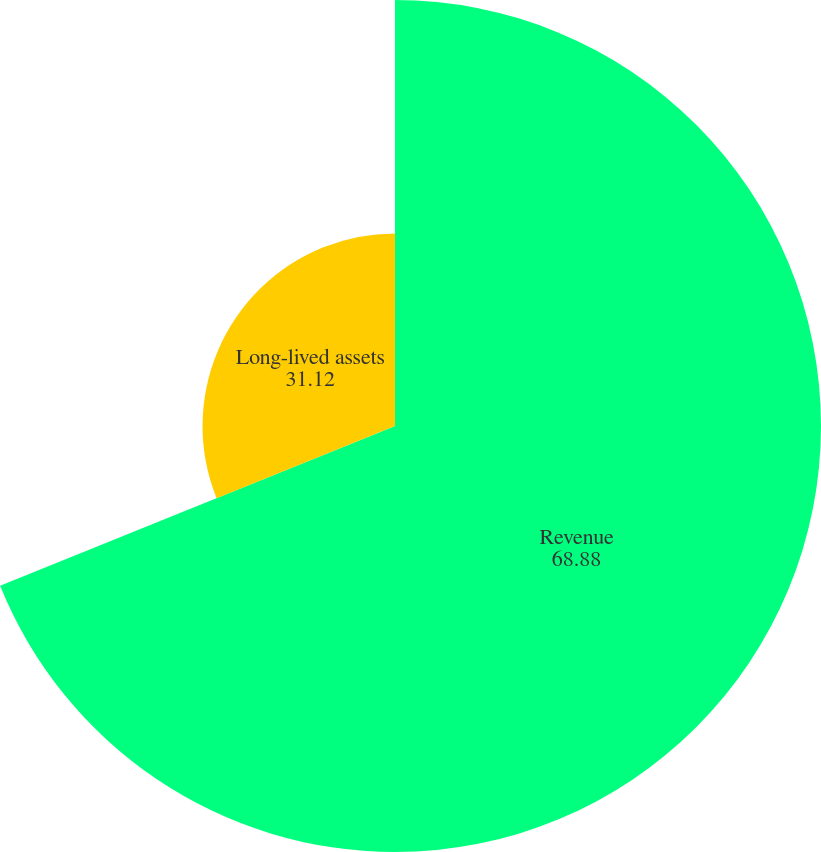Convert chart to OTSL. <chart><loc_0><loc_0><loc_500><loc_500><pie_chart><fcel>Revenue<fcel>Long-lived assets<nl><fcel>68.88%<fcel>31.12%<nl></chart> 